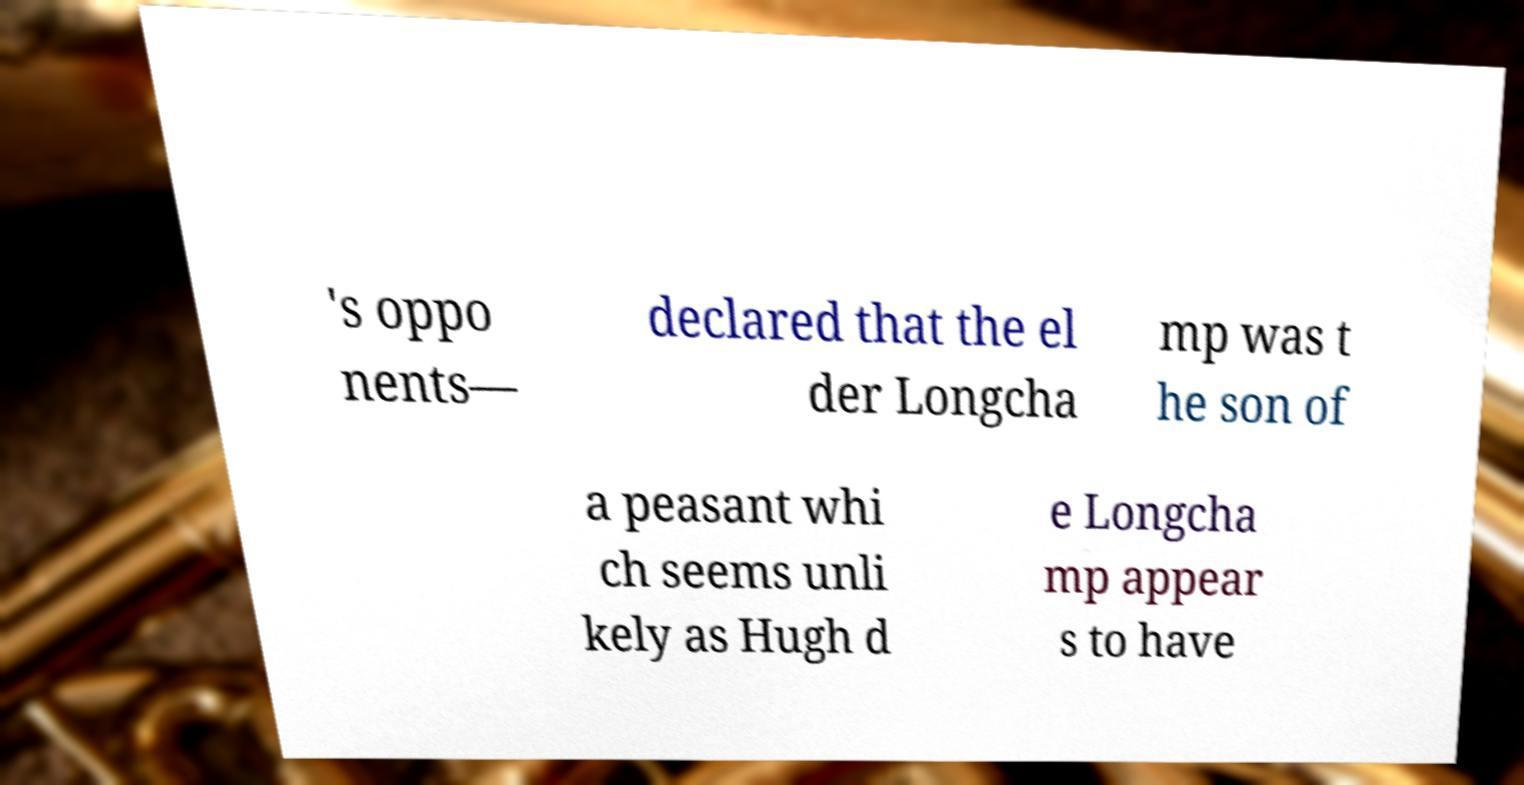What messages or text are displayed in this image? I need them in a readable, typed format. 's oppo nents— declared that the el der Longcha mp was t he son of a peasant whi ch seems unli kely as Hugh d e Longcha mp appear s to have 